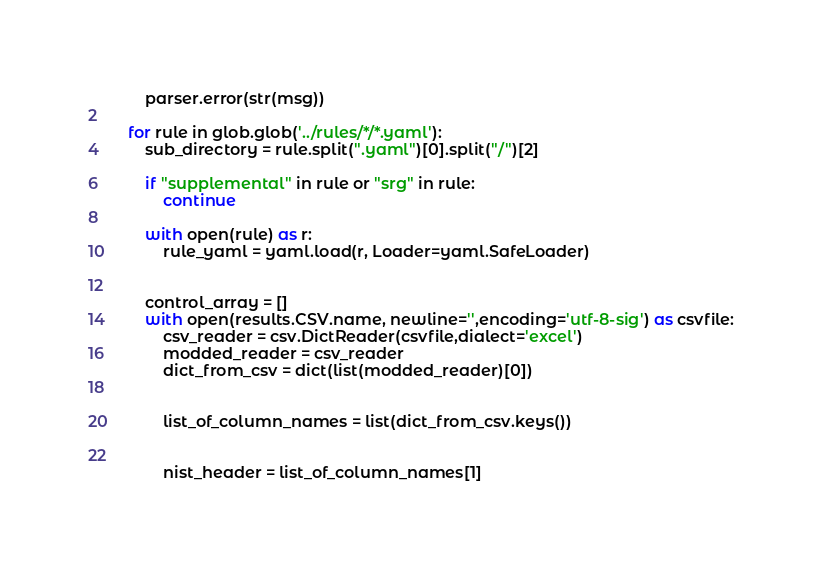<code> <loc_0><loc_0><loc_500><loc_500><_Python_>        parser.error(str(msg))
    
    for rule in glob.glob('../rules/*/*.yaml'):
        sub_directory = rule.split(".yaml")[0].split("/")[2]
        
        if "supplemental" in rule or "srg" in rule:
            continue
        
        with open(rule) as r:
            rule_yaml = yaml.load(r, Loader=yaml.SafeLoader)
      
        
        control_array = []
        with open(results.CSV.name, newline='',encoding='utf-8-sig') as csvfile:
            csv_reader = csv.DictReader(csvfile,dialect='excel')
            modded_reader = csv_reader
            dict_from_csv = dict(list(modded_reader)[0])

            
            list_of_column_names = list(dict_from_csv.keys())


            nist_header = list_of_column_names[1]</code> 